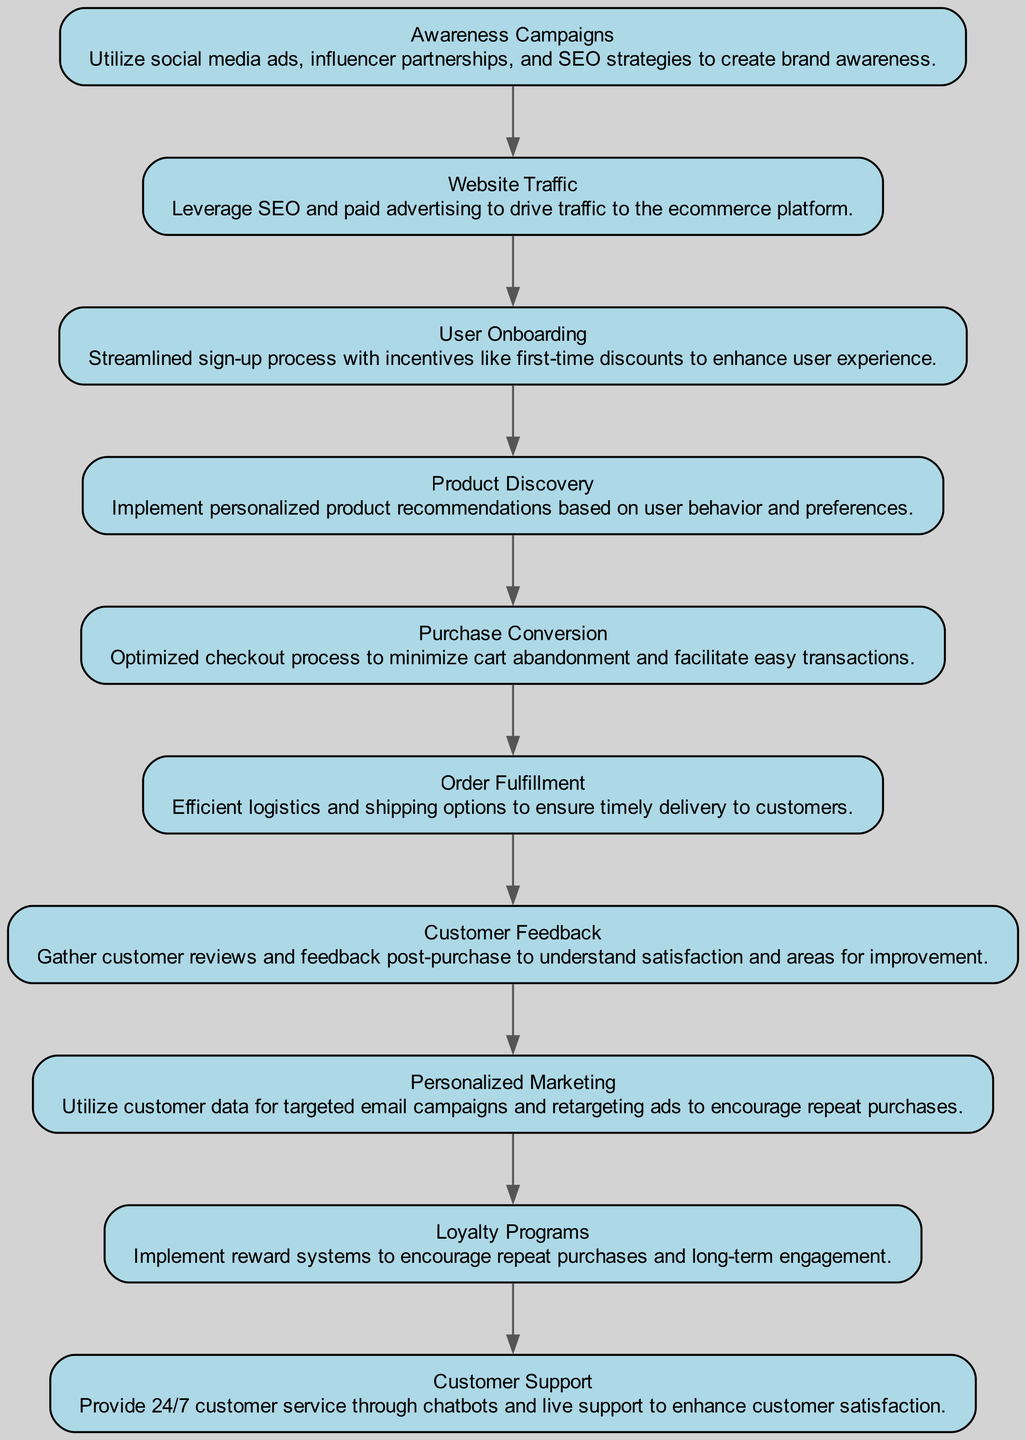What is the first step in the customer journey? The diagram shows "Awareness Campaigns" as the first node, indicating the starting point for customer engagement.
Answer: Awareness Campaigns How many nodes are present in the diagram? By counting each distinct element in the "elements" section, there are a total of 10 nodes representing different stages or actions in the customer journey.
Answer: 10 What is the relationship between "Purchase Conversion" and "Order Fulfillment"? The diagram indicates a direct connection from "Purchase Conversion" to "Order Fulfillment," signifying that successful purchases lead to the fulfillment stage.
Answer: Direct connection What comes directly after "User Onboarding"? Following "User Onboarding" in the flow of the diagram, the next node is "Product Discovery," indicating the sequence of actions in the customer journey.
Answer: Product Discovery Which node follows "Customer Feedback"? "Customer Feedback" leads to "Personalized Marketing" as the next step according to the connections depicted in the diagram.
Answer: Personalized Marketing Which node has the most direct connections leading to it? Analyzing the connections shows that "Customer Support" connects directly to "Loyalty Programs," indicating it has multiple pathways of engagement leading to improved customer relations.
Answer: Loyalty Programs What type of marketing is utilized after gathering customer feedback? After "Customer Feedback," the diagram indicates that "Personalized Marketing" is the subsequent action, highlighting its significance in the journey.
Answer: Personalized Marketing How many edges are there in the diagram? Counting each connection that signifies the flow between nodes, there are 9 edges representing the transitions between different steps in the customer journey.
Answer: 9 What is the last step in the customer journey? The final node in the diagram is "Customer Support," which represents the last stage of engagement aimed at maintaining customer satisfaction and loyalty.
Answer: Customer Support 